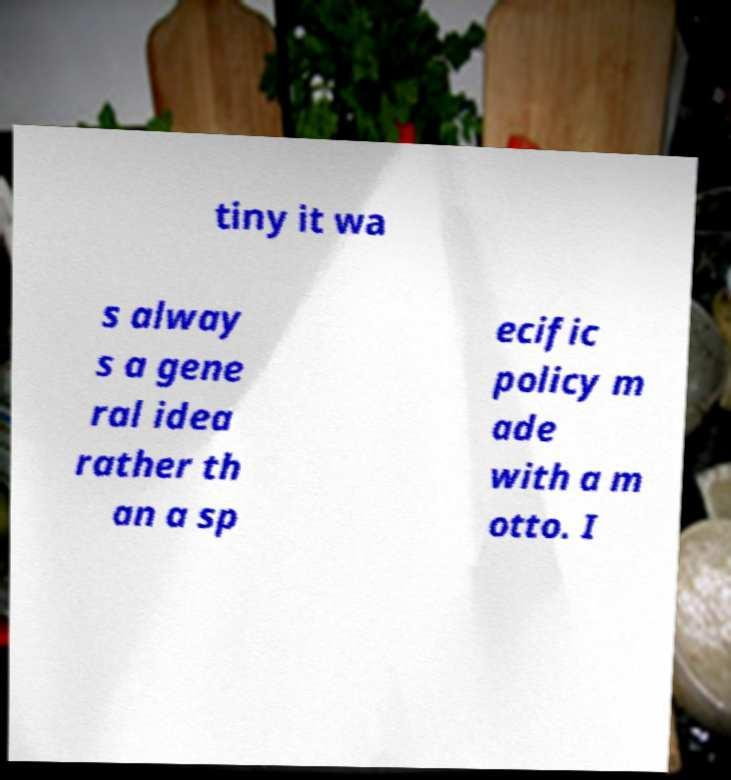Please identify and transcribe the text found in this image. tiny it wa s alway s a gene ral idea rather th an a sp ecific policy m ade with a m otto. I 